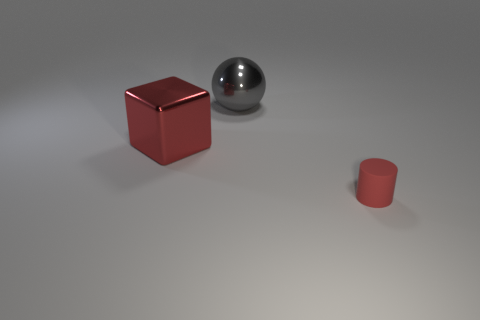What is the shape of the large thing in front of the gray thing?
Offer a terse response. Cube. Does the small rubber cylinder have the same color as the metal thing to the left of the big shiny ball?
Your answer should be compact. Yes. What shape is the large gray object?
Your answer should be compact. Sphere. How many cylinders are big things or large red shiny things?
Provide a short and direct response. 0. What is the thing on the left side of the thing that is behind the big thing left of the large gray shiny ball made of?
Offer a very short reply. Metal. What number of other objects are there of the same size as the gray shiny object?
Give a very brief answer. 1. The block that is the same color as the small thing is what size?
Offer a very short reply. Large. Are there more objects to the left of the gray shiny object than tiny purple shiny things?
Make the answer very short. Yes. Is there a cylinder that has the same color as the ball?
Ensure brevity in your answer.  No. What is the color of the object that is the same size as the gray sphere?
Provide a short and direct response. Red. 